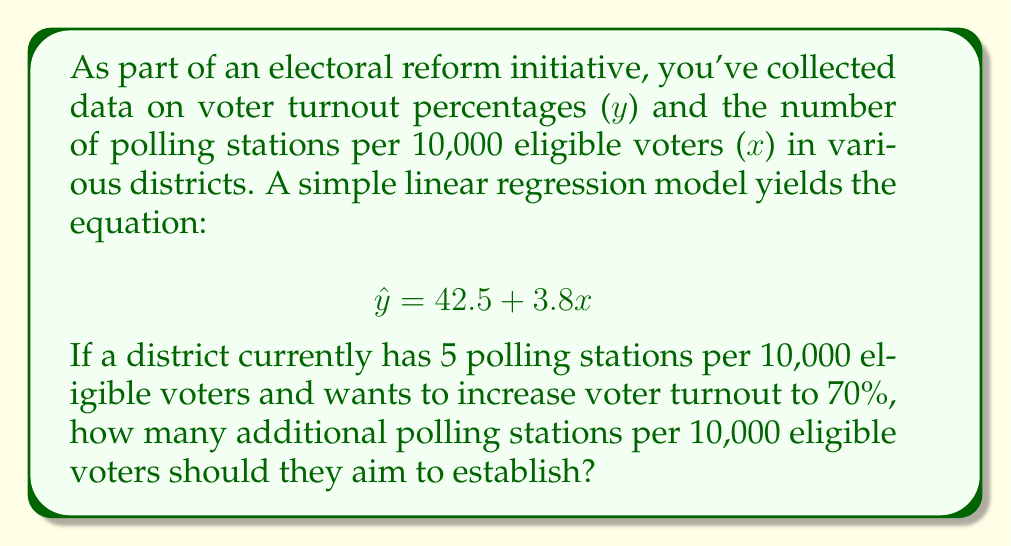Teach me how to tackle this problem. Let's approach this step-by-step:

1) The given regression equation is:
   $$ \hat{y} = 42.5 + 3.8x $$
   where $\hat{y}$ is the predicted voter turnout percentage and $x$ is the number of polling stations per 10,000 eligible voters.

2) We want to find the value of $x$ when $\hat{y} = 70$. Let's substitute these values:
   $$ 70 = 42.5 + 3.8x $$

3) Subtract 42.5 from both sides:
   $$ 27.5 = 3.8x $$

4) Divide both sides by 3.8:
   $$ x = \frac{27.5}{3.8} \approx 7.24 $$

5) This means that to achieve 70% turnout, we need approximately 7.24 polling stations per 10,000 eligible voters.

6) The district currently has 5 polling stations per 10,000 eligible voters.

7) To find the additional number of stations needed:
   $$ 7.24 - 5 = 2.24 $$

8) Since we can't have a fractional polling station, we round up to 3 additional stations.
Answer: 3 additional polling stations per 10,000 eligible voters 